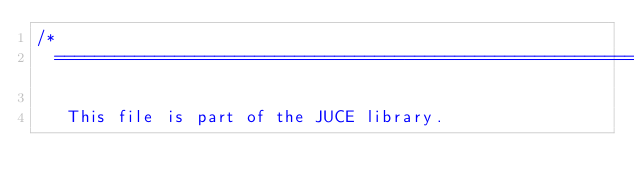Convert code to text. <code><loc_0><loc_0><loc_500><loc_500><_ObjectiveC_>/*
  ==============================================================================

   This file is part of the JUCE library.</code> 